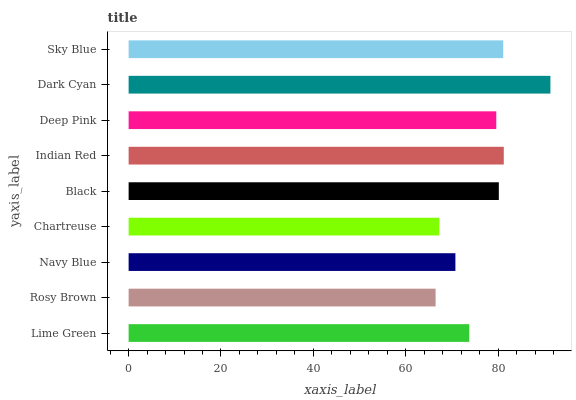Is Rosy Brown the minimum?
Answer yes or no. Yes. Is Dark Cyan the maximum?
Answer yes or no. Yes. Is Navy Blue the minimum?
Answer yes or no. No. Is Navy Blue the maximum?
Answer yes or no. No. Is Navy Blue greater than Rosy Brown?
Answer yes or no. Yes. Is Rosy Brown less than Navy Blue?
Answer yes or no. Yes. Is Rosy Brown greater than Navy Blue?
Answer yes or no. No. Is Navy Blue less than Rosy Brown?
Answer yes or no. No. Is Deep Pink the high median?
Answer yes or no. Yes. Is Deep Pink the low median?
Answer yes or no. Yes. Is Indian Red the high median?
Answer yes or no. No. Is Black the low median?
Answer yes or no. No. 